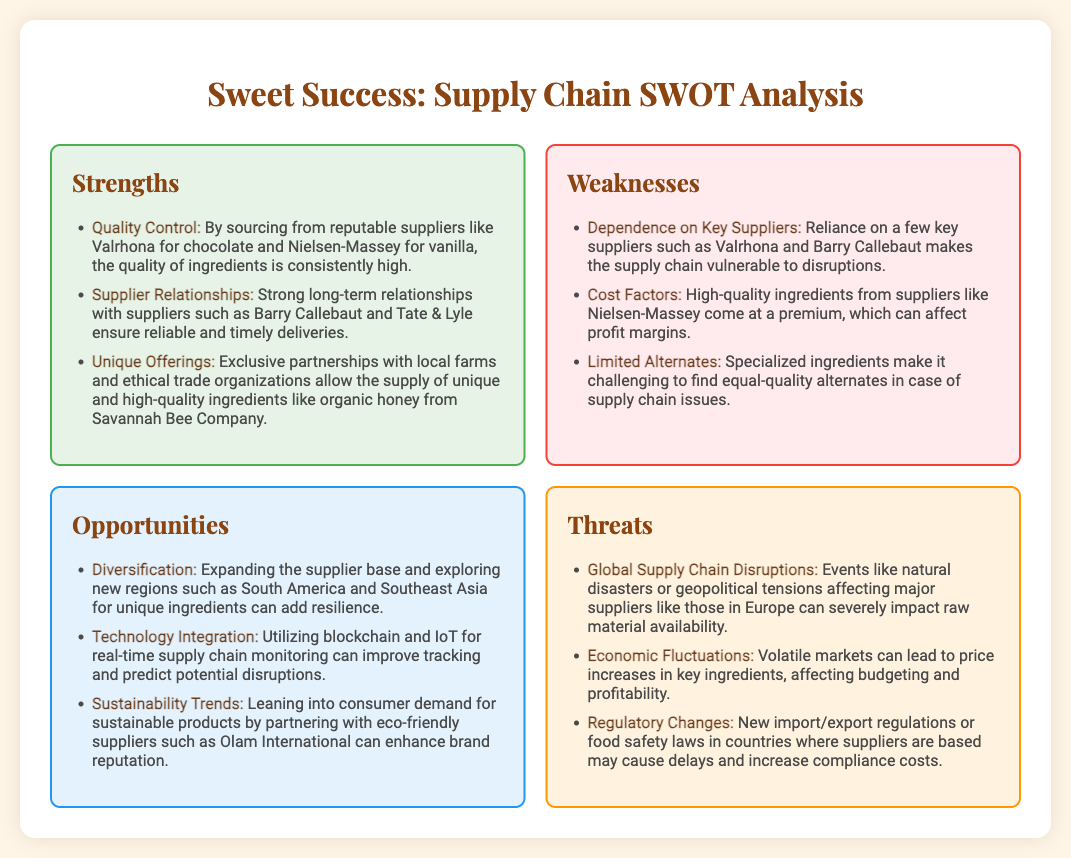What are the three strengths listed? The strengths include Quality Control, Supplier Relationships, and Unique Offerings, as mentioned in the document.
Answer: Quality Control, Supplier Relationships, Unique Offerings Who is a supplier for high-quality chocolate? The document mentions Valrhona as a reputable supplier for chocolate.
Answer: Valrhona What is one weakness related to suppliers? The document states that dependence on key suppliers makes the supply chain vulnerable to disruptions.
Answer: Dependence on Key Suppliers Name one opportunity for enhancing supply chain resilience. Diversification in expanding the supplier base is mentioned as an opportunity for resilience.
Answer: Diversification What economic factor can affect profitability? The document highlights economic fluctuations leading to price increases in key ingredients affecting budgeting and profitability.
Answer: Economic Fluctuations What is a specific threat to the supply chain mentioned? Global supply chain disruptions due to natural disasters or geopolitical tensions are noted as a threat.
Answer: Global Supply Chain Disruptions Which region is suggested for new ingredient sourcing? The document suggests exploring new regions such as South America and Southeast Asia for unique ingredients.
Answer: South America and Southeast Asia What technology could improve tracking in the supply chain? The document mentions utilizing blockchain and IoT for real-time supply chain monitoring as a technology opportunity.
Answer: Blockchain and IoT Which supplier is mentioned for sustainable products? Olam International is mentioned as an eco-friendly supplier aligned with sustainability trends.
Answer: Olam International 